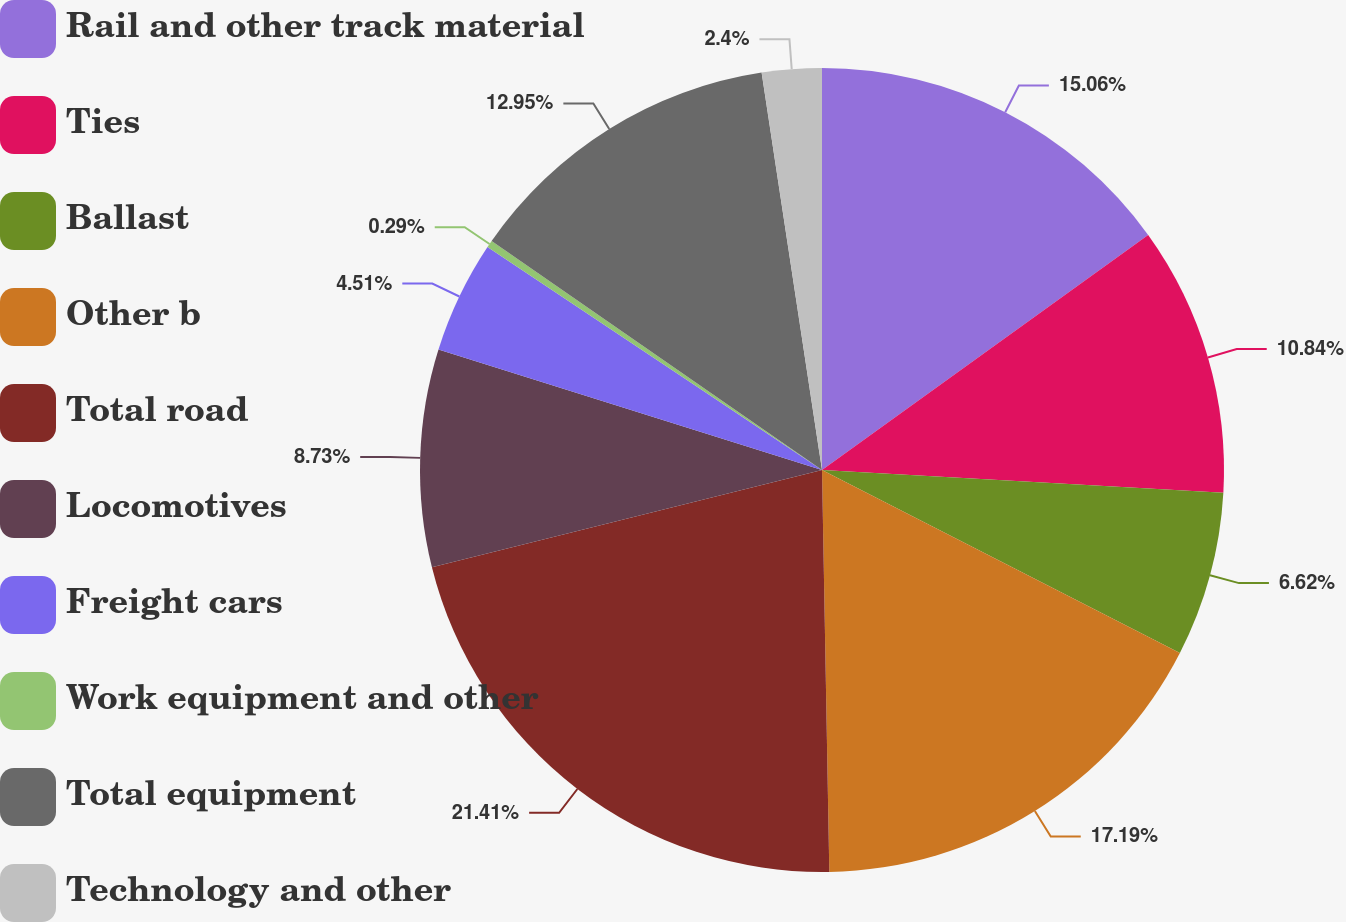<chart> <loc_0><loc_0><loc_500><loc_500><pie_chart><fcel>Rail and other track material<fcel>Ties<fcel>Ballast<fcel>Other b<fcel>Total road<fcel>Locomotives<fcel>Freight cars<fcel>Work equipment and other<fcel>Total equipment<fcel>Technology and other<nl><fcel>15.06%<fcel>10.84%<fcel>6.62%<fcel>17.18%<fcel>21.4%<fcel>8.73%<fcel>4.51%<fcel>0.29%<fcel>12.95%<fcel>2.4%<nl></chart> 